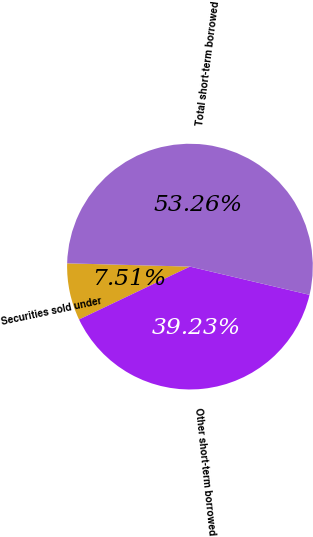Convert chart to OTSL. <chart><loc_0><loc_0><loc_500><loc_500><pie_chart><fcel>Securities sold under<fcel>Other short-term borrowed<fcel>Total short-term borrowed<nl><fcel>7.51%<fcel>39.23%<fcel>53.26%<nl></chart> 